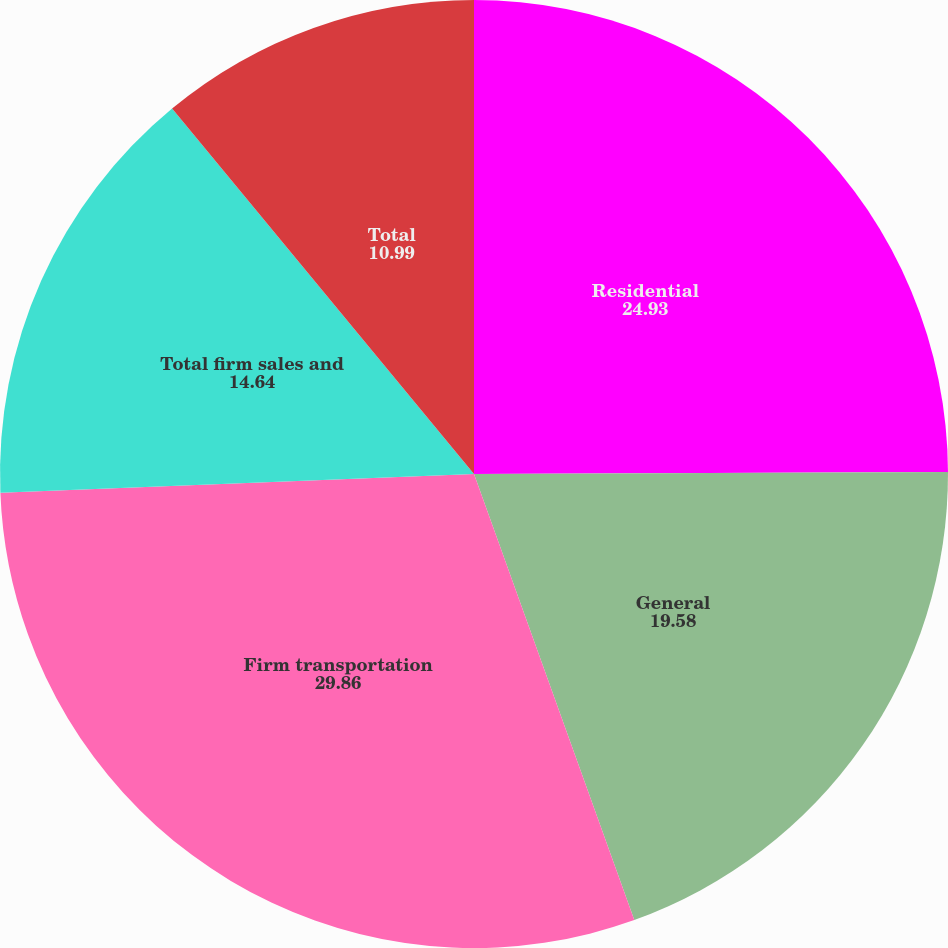Convert chart to OTSL. <chart><loc_0><loc_0><loc_500><loc_500><pie_chart><fcel>Residential<fcel>General<fcel>Firm transportation<fcel>Total firm sales and<fcel>Total<nl><fcel>24.93%<fcel>19.58%<fcel>29.86%<fcel>14.64%<fcel>10.99%<nl></chart> 